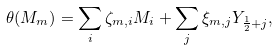Convert formula to latex. <formula><loc_0><loc_0><loc_500><loc_500>\theta ( M _ { m } ) = \sum _ { i } \zeta _ { m , i } M _ { i } + \sum _ { j } \xi _ { m , j } Y _ { \frac { 1 } { 2 } + j } ,</formula> 